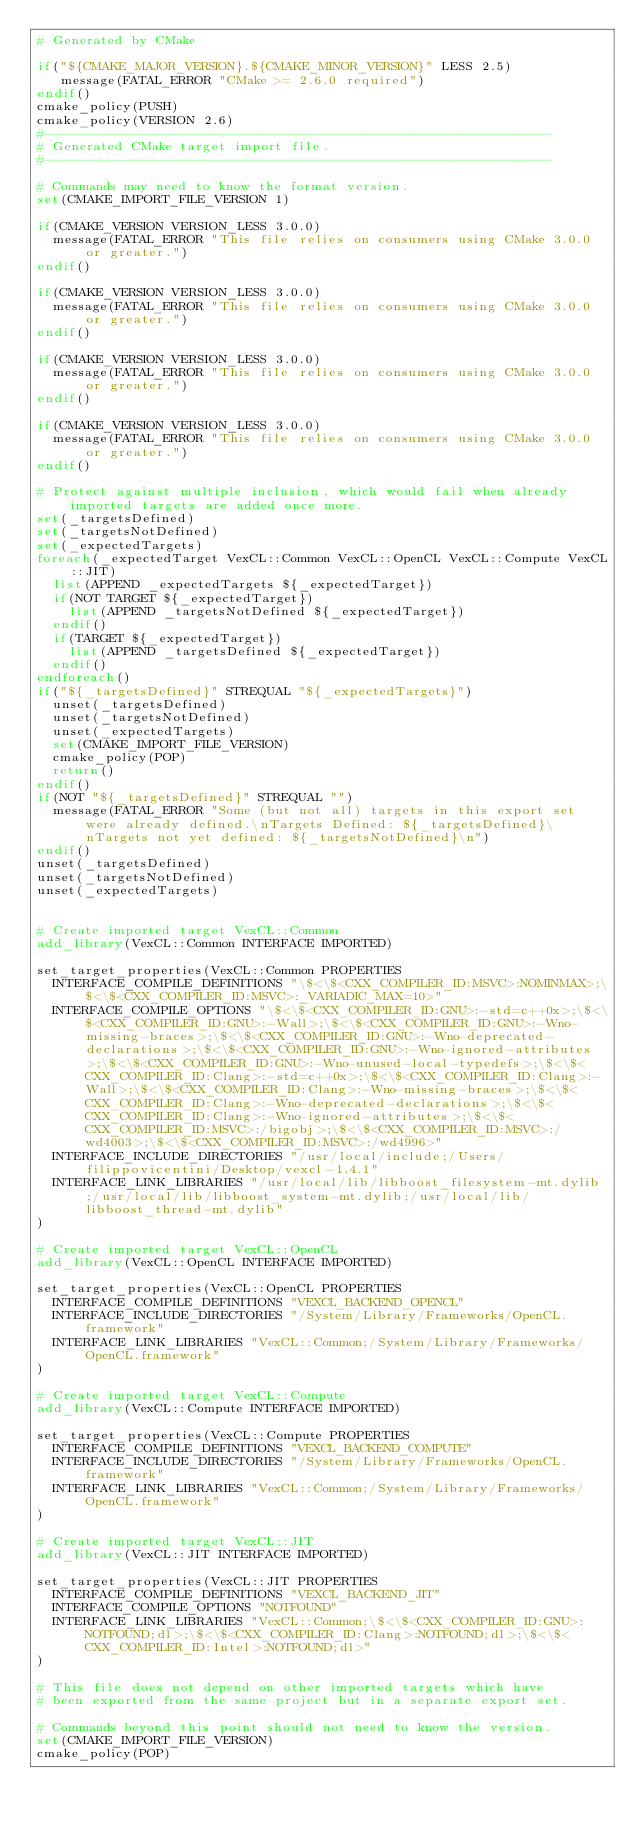Convert code to text. <code><loc_0><loc_0><loc_500><loc_500><_CMake_># Generated by CMake

if("${CMAKE_MAJOR_VERSION}.${CMAKE_MINOR_VERSION}" LESS 2.5)
   message(FATAL_ERROR "CMake >= 2.6.0 required")
endif()
cmake_policy(PUSH)
cmake_policy(VERSION 2.6)
#----------------------------------------------------------------
# Generated CMake target import file.
#----------------------------------------------------------------

# Commands may need to know the format version.
set(CMAKE_IMPORT_FILE_VERSION 1)

if(CMAKE_VERSION VERSION_LESS 3.0.0)
  message(FATAL_ERROR "This file relies on consumers using CMake 3.0.0 or greater.")
endif()

if(CMAKE_VERSION VERSION_LESS 3.0.0)
  message(FATAL_ERROR "This file relies on consumers using CMake 3.0.0 or greater.")
endif()

if(CMAKE_VERSION VERSION_LESS 3.0.0)
  message(FATAL_ERROR "This file relies on consumers using CMake 3.0.0 or greater.")
endif()

if(CMAKE_VERSION VERSION_LESS 3.0.0)
  message(FATAL_ERROR "This file relies on consumers using CMake 3.0.0 or greater.")
endif()

# Protect against multiple inclusion, which would fail when already imported targets are added once more.
set(_targetsDefined)
set(_targetsNotDefined)
set(_expectedTargets)
foreach(_expectedTarget VexCL::Common VexCL::OpenCL VexCL::Compute VexCL::JIT)
  list(APPEND _expectedTargets ${_expectedTarget})
  if(NOT TARGET ${_expectedTarget})
    list(APPEND _targetsNotDefined ${_expectedTarget})
  endif()
  if(TARGET ${_expectedTarget})
    list(APPEND _targetsDefined ${_expectedTarget})
  endif()
endforeach()
if("${_targetsDefined}" STREQUAL "${_expectedTargets}")
  unset(_targetsDefined)
  unset(_targetsNotDefined)
  unset(_expectedTargets)
  set(CMAKE_IMPORT_FILE_VERSION)
  cmake_policy(POP)
  return()
endif()
if(NOT "${_targetsDefined}" STREQUAL "")
  message(FATAL_ERROR "Some (but not all) targets in this export set were already defined.\nTargets Defined: ${_targetsDefined}\nTargets not yet defined: ${_targetsNotDefined}\n")
endif()
unset(_targetsDefined)
unset(_targetsNotDefined)
unset(_expectedTargets)


# Create imported target VexCL::Common
add_library(VexCL::Common INTERFACE IMPORTED)

set_target_properties(VexCL::Common PROPERTIES
  INTERFACE_COMPILE_DEFINITIONS "\$<\$<CXX_COMPILER_ID:MSVC>:NOMINMAX>;\$<\$<CXX_COMPILER_ID:MSVC>:_VARIADIC_MAX=10>"
  INTERFACE_COMPILE_OPTIONS "\$<\$<CXX_COMPILER_ID:GNU>:-std=c++0x>;\$<\$<CXX_COMPILER_ID:GNU>:-Wall>;\$<\$<CXX_COMPILER_ID:GNU>:-Wno-missing-braces>;\$<\$<CXX_COMPILER_ID:GNU>:-Wno-deprecated-declarations>;\$<\$<CXX_COMPILER_ID:GNU>:-Wno-ignored-attributes>;\$<\$<CXX_COMPILER_ID:GNU>:-Wno-unused-local-typedefs>;\$<\$<CXX_COMPILER_ID:Clang>:-std=c++0x>;\$<\$<CXX_COMPILER_ID:Clang>:-Wall>;\$<\$<CXX_COMPILER_ID:Clang>:-Wno-missing-braces>;\$<\$<CXX_COMPILER_ID:Clang>:-Wno-deprecated-declarations>;\$<\$<CXX_COMPILER_ID:Clang>:-Wno-ignored-attributes>;\$<\$<CXX_COMPILER_ID:MSVC>:/bigobj>;\$<\$<CXX_COMPILER_ID:MSVC>:/wd4003>;\$<\$<CXX_COMPILER_ID:MSVC>:/wd4996>"
  INTERFACE_INCLUDE_DIRECTORIES "/usr/local/include;/Users/filippovicentini/Desktop/vexcl-1.4.1"
  INTERFACE_LINK_LIBRARIES "/usr/local/lib/libboost_filesystem-mt.dylib;/usr/local/lib/libboost_system-mt.dylib;/usr/local/lib/libboost_thread-mt.dylib"
)

# Create imported target VexCL::OpenCL
add_library(VexCL::OpenCL INTERFACE IMPORTED)

set_target_properties(VexCL::OpenCL PROPERTIES
  INTERFACE_COMPILE_DEFINITIONS "VEXCL_BACKEND_OPENCL"
  INTERFACE_INCLUDE_DIRECTORIES "/System/Library/Frameworks/OpenCL.framework"
  INTERFACE_LINK_LIBRARIES "VexCL::Common;/System/Library/Frameworks/OpenCL.framework"
)

# Create imported target VexCL::Compute
add_library(VexCL::Compute INTERFACE IMPORTED)

set_target_properties(VexCL::Compute PROPERTIES
  INTERFACE_COMPILE_DEFINITIONS "VEXCL_BACKEND_COMPUTE"
  INTERFACE_INCLUDE_DIRECTORIES "/System/Library/Frameworks/OpenCL.framework"
  INTERFACE_LINK_LIBRARIES "VexCL::Common;/System/Library/Frameworks/OpenCL.framework"
)

# Create imported target VexCL::JIT
add_library(VexCL::JIT INTERFACE IMPORTED)

set_target_properties(VexCL::JIT PROPERTIES
  INTERFACE_COMPILE_DEFINITIONS "VEXCL_BACKEND_JIT"
  INTERFACE_COMPILE_OPTIONS "NOTFOUND"
  INTERFACE_LINK_LIBRARIES "VexCL::Common;\$<\$<CXX_COMPILER_ID:GNU>:NOTFOUND;dl>;\$<\$<CXX_COMPILER_ID:Clang>:NOTFOUND;dl>;\$<\$<CXX_COMPILER_ID:Intel>:NOTFOUND;dl>"
)

# This file does not depend on other imported targets which have
# been exported from the same project but in a separate export set.

# Commands beyond this point should not need to know the version.
set(CMAKE_IMPORT_FILE_VERSION)
cmake_policy(POP)
</code> 